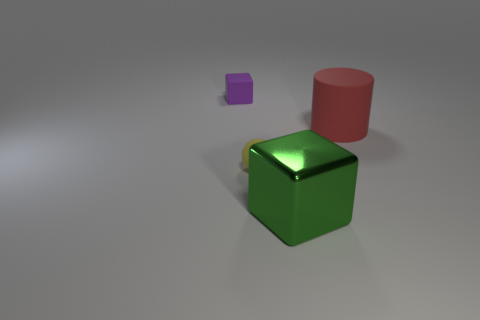There is a green thing that is the same shape as the purple object; what is its size?
Provide a short and direct response. Large. There is a large cylinder; is its color the same as the block behind the green cube?
Your response must be concise. No. Do the rubber cube and the metal thing have the same color?
Your response must be concise. No. Are there fewer red things than big gray balls?
Offer a terse response. No. What number of other objects are there of the same color as the large cube?
Offer a terse response. 0. How many purple objects are there?
Provide a succinct answer. 1. Are there fewer large red things in front of the red rubber thing than green blocks?
Provide a short and direct response. Yes. Are the tiny object in front of the big red thing and the purple block made of the same material?
Give a very brief answer. Yes. There is a small object that is to the left of the tiny yellow sphere in front of the small thing to the left of the small yellow matte sphere; what shape is it?
Provide a short and direct response. Cube. Are there any yellow rubber things that have the same size as the purple block?
Give a very brief answer. Yes. 